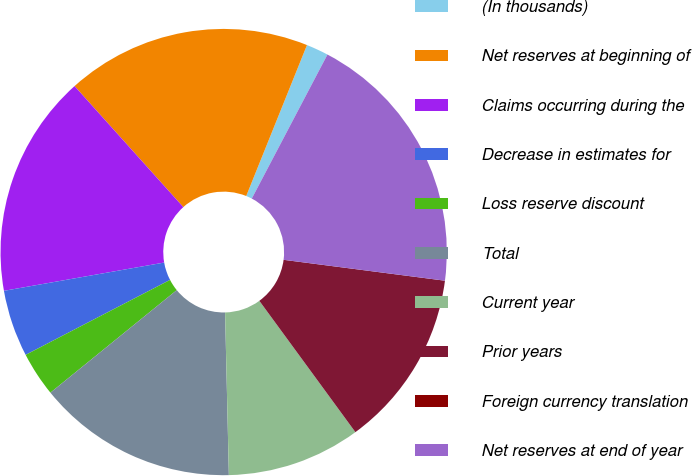<chart> <loc_0><loc_0><loc_500><loc_500><pie_chart><fcel>(In thousands)<fcel>Net reserves at beginning of<fcel>Claims occurring during the<fcel>Decrease in estimates for<fcel>Loss reserve discount<fcel>Total<fcel>Current year<fcel>Prior years<fcel>Foreign currency translation<fcel>Net reserves at end of year<nl><fcel>1.61%<fcel>17.74%<fcel>16.13%<fcel>4.84%<fcel>3.23%<fcel>14.52%<fcel>9.68%<fcel>12.9%<fcel>0.0%<fcel>19.35%<nl></chart> 